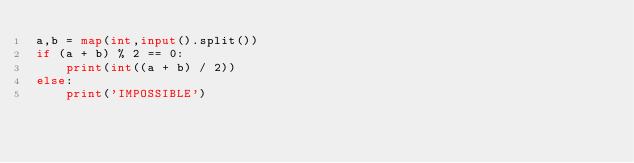Convert code to text. <code><loc_0><loc_0><loc_500><loc_500><_Python_>a,b = map(int,input().split())
if (a + b) % 2 == 0:
    print(int((a + b) / 2))
else:
    print('IMPOSSIBLE')</code> 